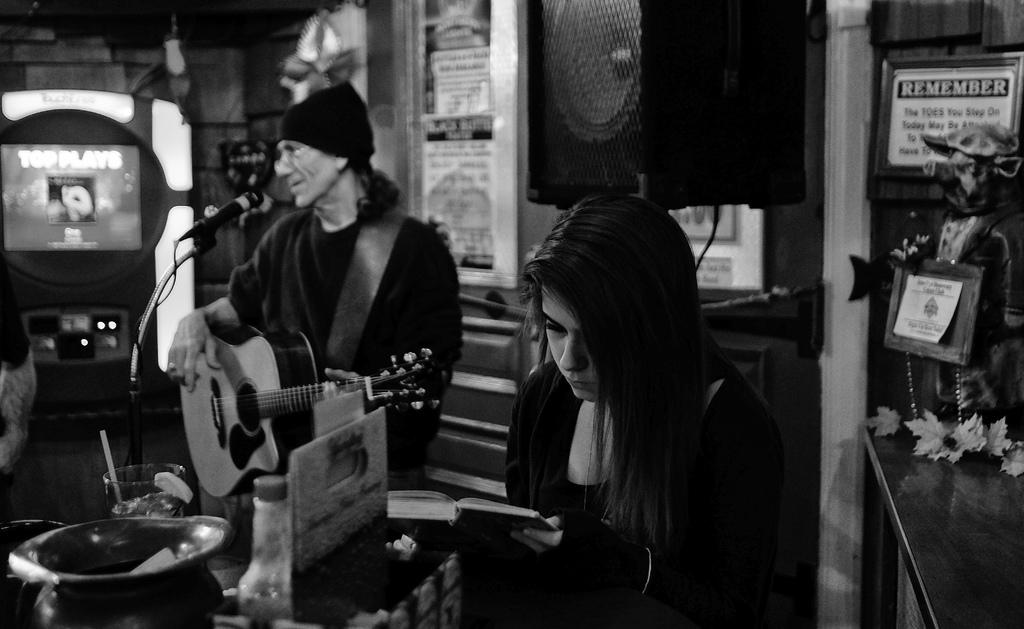What is the person in the image holding? The person is holding a book in the image. What activity is the man in the image engaged in? The man is playing a guitar in the image. What device can be seen in the image that might be used for amplifying sound? There is a speaker visible in the image. What message is conveyed by the note in the image? The note in the image has the text "remember" written on it. What color is the paint used to decorate the guitar in the image? There is no paint or decoration mentioned on the guitar in the image; it is simply being played by the man. 